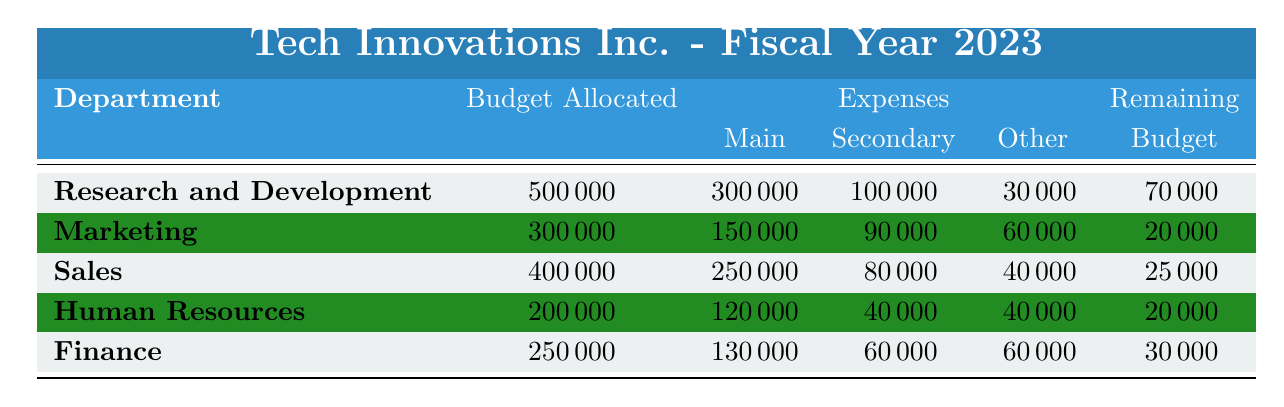What is the total budget allocated to all departments? To find the total budget allocated, sum the individual budgets: 500000 (R&D) + 300000 (Marketing) + 400000 (Sales) + 200000 (HR) + 250000 (Finance) = 1650000.
Answer: 1650000 How much did the Sales department spend on commissions? The Sales department spent 80000 on commissions, which is listed directly in the expenses for that department.
Answer: 80000 Which department has the highest remaining budget? Comparing the remaining budgets: R&D 70000, Marketing 20000, Sales 25000, HR 20000, Finance 30000. R&D has the highest remaining budget at 70000.
Answer: Research and Development Is the total spent by the Human Resources department more than 150000? The total expenses for HR are calculated as: 120000 (Salaries) + 40000 (Recruitment) + 20000 (Training) + 20000 (Miscellaneous) = 200000. Since 200000 is greater than 150000, the statement is true.
Answer: Yes What is the difference in budget allocation between the Finance and Marketing departments? The budget allocated to Finance is 250000 and for Marketing is 300000. The difference is 300000 - 250000 = 50000.
Answer: 50000 Which department spent the least in total? Calculate total expenses for each department: R&D 430000, Marketing 250000, Sales 375000, HR 200000, Finance 250000. HR has the least total expenses at 200000.
Answer: Human Resources Does the Marketing department have a remaining budget greater than the Sales department? Remaining budgets: Marketing has 20000 and Sales has 25000. Since 20000 is less than 25000, the statement is false.
Answer: No What percentage of the R&D budget was used for salaries? R&D salaries are 300000. Percentage calculation: (300000 / 500000) * 100 = 60%.
Answer: 60% What is the average remaining budget across all departments? Sum of remaining budgets: 70000 (R&D) + 20000 (Marketing) + 25000 (Sales) + 20000 (HR) + 30000 (Finance) = 165000. Average: 165000 / 5 = 33000.
Answer: 33000 